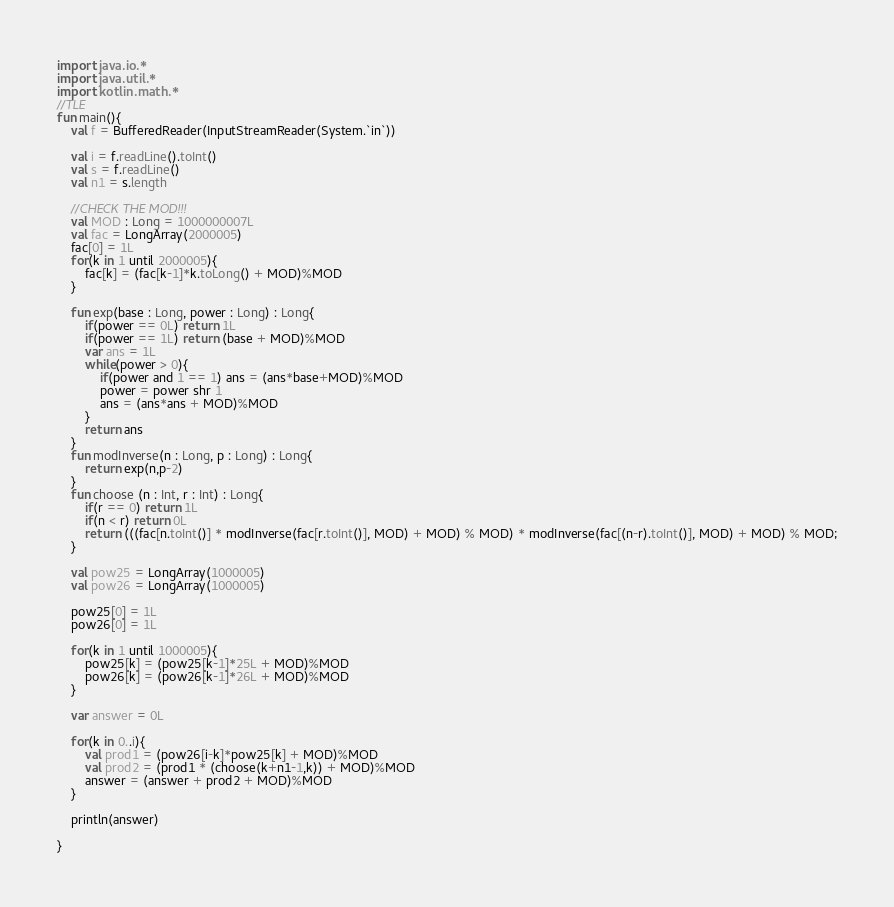Convert code to text. <code><loc_0><loc_0><loc_500><loc_500><_Kotlin_>import java.io.*
import java.util.*
import kotlin.math.*
//TLE
fun main(){
	val f = BufferedReader(InputStreamReader(System.`in`))

	val i = f.readLine().toInt()
	val s = f.readLine()
	val n1 = s.length

	//CHECK THE MOD!!!
	val MOD : Long = 1000000007L
	val fac = LongArray(2000005)
	fac[0] = 1L
	for(k in 1 until 2000005){
		fac[k] = (fac[k-1]*k.toLong() + MOD)%MOD
	}

	fun exp(base : Long, power : Long) : Long{
		if(power == 0L) return 1L
		if(power == 1L) return (base + MOD)%MOD
		var ans = 1L
		while(power > 0){
			if(power and 1 == 1) ans = (ans*base+MOD)%MOD
			power = power shr 1
			ans = (ans*ans + MOD)%MOD
		}
		return ans
	}
	fun modInverse(n : Long, p : Long) : Long{
		return exp(n,p-2)
	}
	fun choose (n : Int, r : Int) : Long{
		if(r == 0) return 1L
		if(n < r) return 0L
		return (((fac[n.toInt()] * modInverse(fac[r.toInt()], MOD) + MOD) % MOD) * modInverse(fac[(n-r).toInt()], MOD) + MOD) % MOD;
	}

	val pow25 = LongArray(1000005)
	val pow26 = LongArray(1000005)

	pow25[0] = 1L
	pow26[0] = 1L

	for(k in 1 until 1000005){
		pow25[k] = (pow25[k-1]*25L + MOD)%MOD
		pow26[k] = (pow26[k-1]*26L + MOD)%MOD
	}

	var answer = 0L

	for(k in 0..i){
		val prod1 = (pow26[i-k]*pow25[k] + MOD)%MOD
		val prod2 = (prod1 * (choose(k+n1-1,k)) + MOD)%MOD
		answer = (answer + prod2 + MOD)%MOD
	}

	println(answer)

}
</code> 